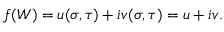Convert formula to latex. <formula><loc_0><loc_0><loc_500><loc_500>f ( W ) = u ( \sigma , \tau ) + i v ( \sigma , \tau ) = u + i v .</formula> 